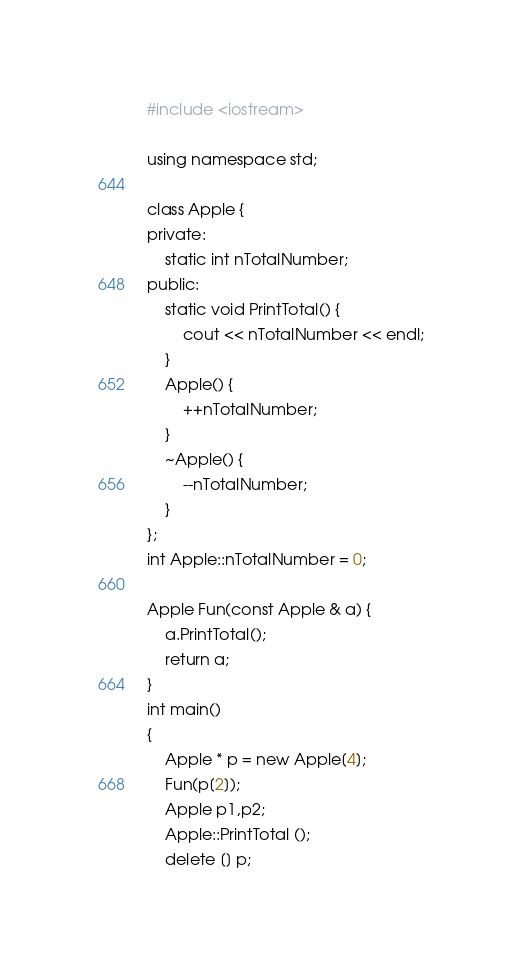Convert code to text. <code><loc_0><loc_0><loc_500><loc_500><_C++_>#include <iostream>

using namespace std;

class Apple {
private:
    static int nTotalNumber;
public:
    static void PrintTotal() {
		cout << nTotalNumber << endl;
	}
    Apple() {
        ++nTotalNumber;
    }
    ~Apple() {
        --nTotalNumber;
    }
};
int Apple::nTotalNumber = 0;

Apple Fun(const Apple & a) {
	a.PrintTotal();
	return a;
}
int main()
{
	Apple * p = new Apple[4];
	Fun(p[2]);
	Apple p1,p2;
	Apple::PrintTotal ();
	delete [] p;</code> 